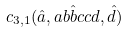<formula> <loc_0><loc_0><loc_500><loc_500>c _ { 3 , 1 } ( \hat { a } , a b \hat { b } c c d , \hat { d } )</formula> 